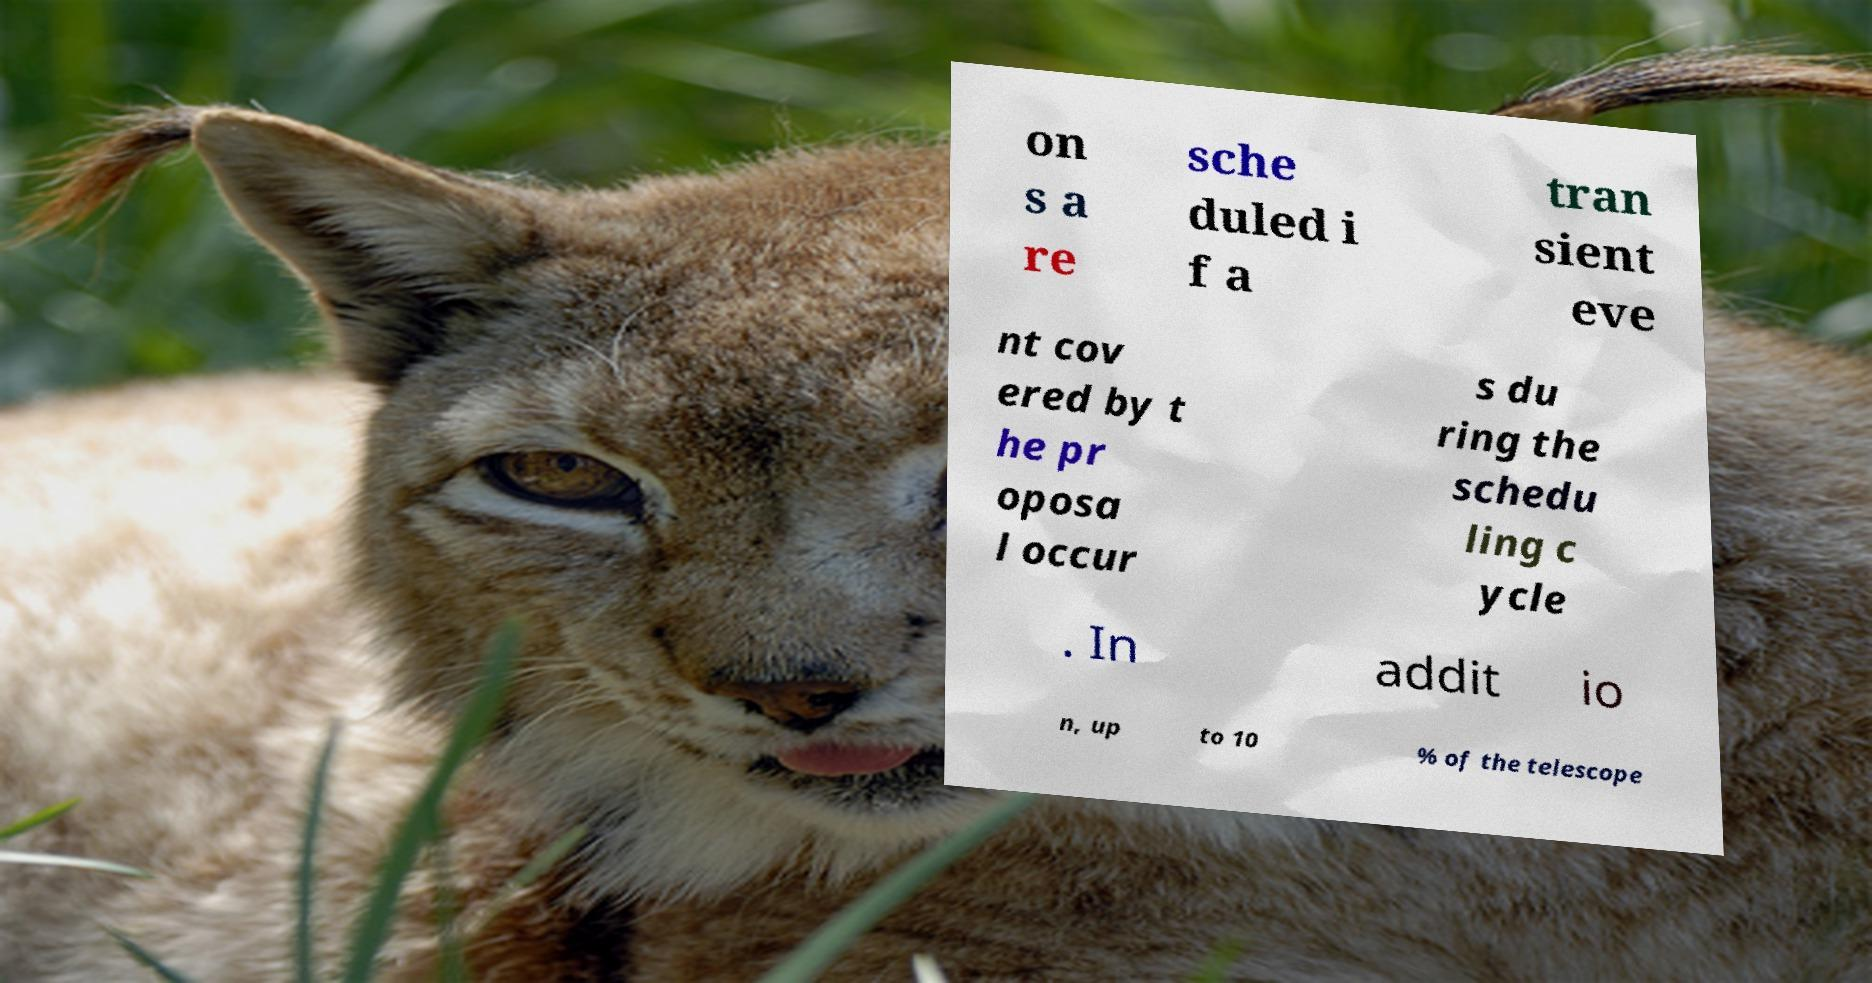What messages or text are displayed in this image? I need them in a readable, typed format. on s a re sche duled i f a tran sient eve nt cov ered by t he pr oposa l occur s du ring the schedu ling c ycle . In addit io n, up to 10 % of the telescope 